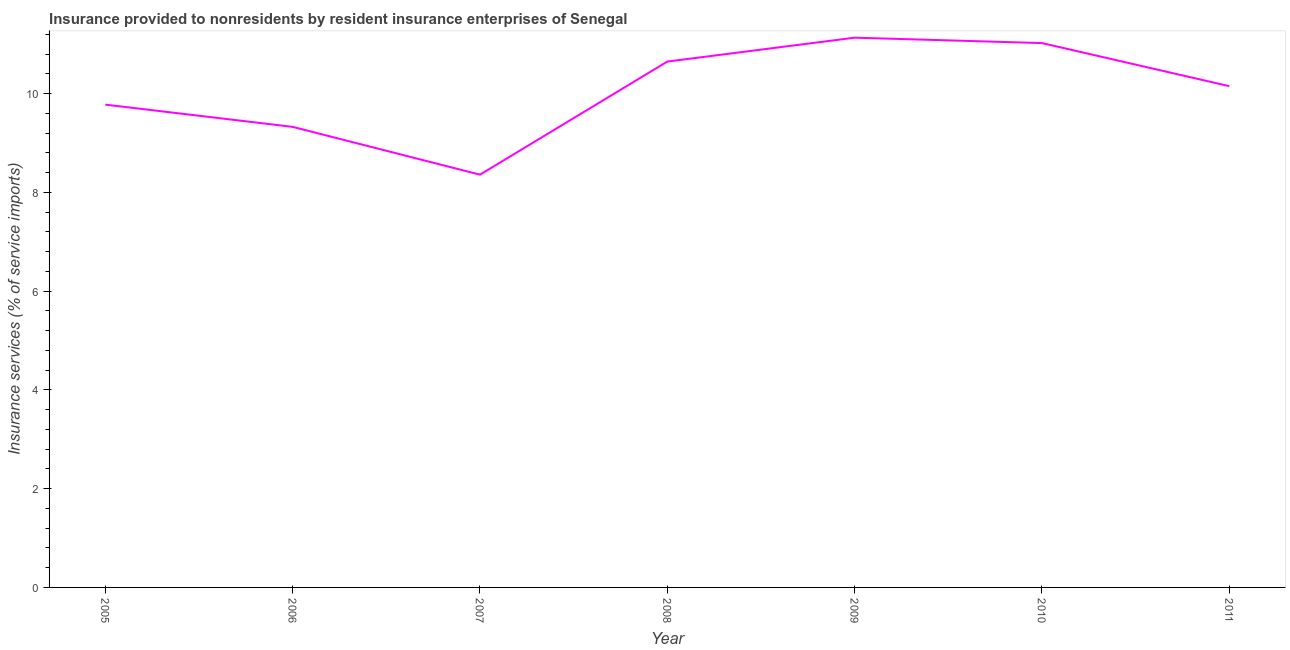What is the insurance and financial services in 2011?
Offer a terse response. 10.15. Across all years, what is the maximum insurance and financial services?
Offer a terse response. 11.13. Across all years, what is the minimum insurance and financial services?
Your answer should be very brief. 8.36. In which year was the insurance and financial services maximum?
Give a very brief answer. 2009. What is the sum of the insurance and financial services?
Your answer should be very brief. 70.43. What is the difference between the insurance and financial services in 2006 and 2010?
Give a very brief answer. -1.7. What is the average insurance and financial services per year?
Offer a terse response. 10.06. What is the median insurance and financial services?
Keep it short and to the point. 10.15. In how many years, is the insurance and financial services greater than 2.4 %?
Your answer should be very brief. 7. Do a majority of the years between 2005 and 2008 (inclusive) have insurance and financial services greater than 6.8 %?
Your answer should be compact. Yes. What is the ratio of the insurance and financial services in 2005 to that in 2009?
Offer a terse response. 0.88. Is the insurance and financial services in 2005 less than that in 2007?
Make the answer very short. No. What is the difference between the highest and the second highest insurance and financial services?
Ensure brevity in your answer.  0.11. Is the sum of the insurance and financial services in 2007 and 2010 greater than the maximum insurance and financial services across all years?
Give a very brief answer. Yes. What is the difference between the highest and the lowest insurance and financial services?
Provide a short and direct response. 2.77. In how many years, is the insurance and financial services greater than the average insurance and financial services taken over all years?
Your response must be concise. 4. Are the values on the major ticks of Y-axis written in scientific E-notation?
Make the answer very short. No. What is the title of the graph?
Keep it short and to the point. Insurance provided to nonresidents by resident insurance enterprises of Senegal. What is the label or title of the Y-axis?
Your answer should be very brief. Insurance services (% of service imports). What is the Insurance services (% of service imports) of 2005?
Keep it short and to the point. 9.78. What is the Insurance services (% of service imports) of 2006?
Keep it short and to the point. 9.33. What is the Insurance services (% of service imports) of 2007?
Ensure brevity in your answer.  8.36. What is the Insurance services (% of service imports) of 2008?
Offer a terse response. 10.65. What is the Insurance services (% of service imports) of 2009?
Your answer should be compact. 11.13. What is the Insurance services (% of service imports) of 2010?
Make the answer very short. 11.03. What is the Insurance services (% of service imports) of 2011?
Ensure brevity in your answer.  10.15. What is the difference between the Insurance services (% of service imports) in 2005 and 2006?
Make the answer very short. 0.45. What is the difference between the Insurance services (% of service imports) in 2005 and 2007?
Offer a terse response. 1.42. What is the difference between the Insurance services (% of service imports) in 2005 and 2008?
Your answer should be very brief. -0.87. What is the difference between the Insurance services (% of service imports) in 2005 and 2009?
Your response must be concise. -1.36. What is the difference between the Insurance services (% of service imports) in 2005 and 2010?
Keep it short and to the point. -1.25. What is the difference between the Insurance services (% of service imports) in 2005 and 2011?
Keep it short and to the point. -0.37. What is the difference between the Insurance services (% of service imports) in 2006 and 2007?
Your answer should be very brief. 0.97. What is the difference between the Insurance services (% of service imports) in 2006 and 2008?
Your response must be concise. -1.32. What is the difference between the Insurance services (% of service imports) in 2006 and 2009?
Your response must be concise. -1.81. What is the difference between the Insurance services (% of service imports) in 2006 and 2010?
Provide a short and direct response. -1.7. What is the difference between the Insurance services (% of service imports) in 2006 and 2011?
Keep it short and to the point. -0.82. What is the difference between the Insurance services (% of service imports) in 2007 and 2008?
Ensure brevity in your answer.  -2.29. What is the difference between the Insurance services (% of service imports) in 2007 and 2009?
Provide a succinct answer. -2.77. What is the difference between the Insurance services (% of service imports) in 2007 and 2010?
Give a very brief answer. -2.67. What is the difference between the Insurance services (% of service imports) in 2007 and 2011?
Keep it short and to the point. -1.79. What is the difference between the Insurance services (% of service imports) in 2008 and 2009?
Provide a succinct answer. -0.48. What is the difference between the Insurance services (% of service imports) in 2008 and 2010?
Your answer should be compact. -0.37. What is the difference between the Insurance services (% of service imports) in 2008 and 2011?
Offer a terse response. 0.5. What is the difference between the Insurance services (% of service imports) in 2009 and 2010?
Offer a very short reply. 0.11. What is the difference between the Insurance services (% of service imports) in 2009 and 2011?
Offer a very short reply. 0.98. What is the difference between the Insurance services (% of service imports) in 2010 and 2011?
Provide a short and direct response. 0.87. What is the ratio of the Insurance services (% of service imports) in 2005 to that in 2006?
Give a very brief answer. 1.05. What is the ratio of the Insurance services (% of service imports) in 2005 to that in 2007?
Ensure brevity in your answer.  1.17. What is the ratio of the Insurance services (% of service imports) in 2005 to that in 2008?
Ensure brevity in your answer.  0.92. What is the ratio of the Insurance services (% of service imports) in 2005 to that in 2009?
Offer a terse response. 0.88. What is the ratio of the Insurance services (% of service imports) in 2005 to that in 2010?
Keep it short and to the point. 0.89. What is the ratio of the Insurance services (% of service imports) in 2006 to that in 2007?
Provide a succinct answer. 1.12. What is the ratio of the Insurance services (% of service imports) in 2006 to that in 2008?
Your response must be concise. 0.88. What is the ratio of the Insurance services (% of service imports) in 2006 to that in 2009?
Provide a short and direct response. 0.84. What is the ratio of the Insurance services (% of service imports) in 2006 to that in 2010?
Offer a very short reply. 0.85. What is the ratio of the Insurance services (% of service imports) in 2006 to that in 2011?
Your response must be concise. 0.92. What is the ratio of the Insurance services (% of service imports) in 2007 to that in 2008?
Offer a terse response. 0.79. What is the ratio of the Insurance services (% of service imports) in 2007 to that in 2009?
Keep it short and to the point. 0.75. What is the ratio of the Insurance services (% of service imports) in 2007 to that in 2010?
Your answer should be very brief. 0.76. What is the ratio of the Insurance services (% of service imports) in 2007 to that in 2011?
Keep it short and to the point. 0.82. What is the ratio of the Insurance services (% of service imports) in 2008 to that in 2009?
Offer a very short reply. 0.96. What is the ratio of the Insurance services (% of service imports) in 2008 to that in 2010?
Provide a succinct answer. 0.97. What is the ratio of the Insurance services (% of service imports) in 2008 to that in 2011?
Make the answer very short. 1.05. What is the ratio of the Insurance services (% of service imports) in 2009 to that in 2011?
Provide a succinct answer. 1.1. What is the ratio of the Insurance services (% of service imports) in 2010 to that in 2011?
Your answer should be compact. 1.09. 